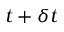Convert formula to latex. <formula><loc_0><loc_0><loc_500><loc_500>t + \delta t</formula> 